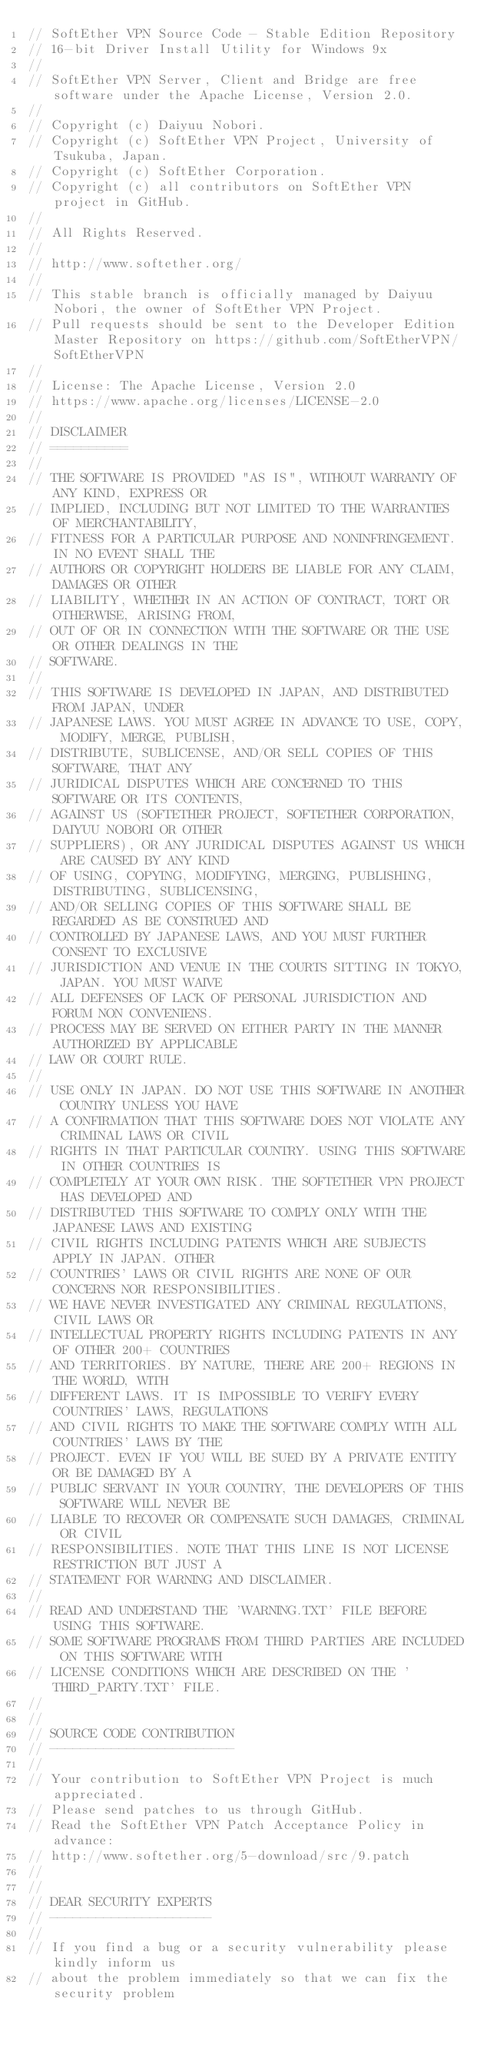Convert code to text. <code><loc_0><loc_0><loc_500><loc_500><_C_>// SoftEther VPN Source Code - Stable Edition Repository
// 16-bit Driver Install Utility for Windows 9x
// 
// SoftEther VPN Server, Client and Bridge are free software under the Apache License, Version 2.0.
// 
// Copyright (c) Daiyuu Nobori.
// Copyright (c) SoftEther VPN Project, University of Tsukuba, Japan.
// Copyright (c) SoftEther Corporation.
// Copyright (c) all contributors on SoftEther VPN project in GitHub.
// 
// All Rights Reserved.
// 
// http://www.softether.org/
// 
// This stable branch is officially managed by Daiyuu Nobori, the owner of SoftEther VPN Project.
// Pull requests should be sent to the Developer Edition Master Repository on https://github.com/SoftEtherVPN/SoftEtherVPN
// 
// License: The Apache License, Version 2.0
// https://www.apache.org/licenses/LICENSE-2.0
// 
// DISCLAIMER
// ==========
// 
// THE SOFTWARE IS PROVIDED "AS IS", WITHOUT WARRANTY OF ANY KIND, EXPRESS OR
// IMPLIED, INCLUDING BUT NOT LIMITED TO THE WARRANTIES OF MERCHANTABILITY,
// FITNESS FOR A PARTICULAR PURPOSE AND NONINFRINGEMENT. IN NO EVENT SHALL THE
// AUTHORS OR COPYRIGHT HOLDERS BE LIABLE FOR ANY CLAIM, DAMAGES OR OTHER
// LIABILITY, WHETHER IN AN ACTION OF CONTRACT, TORT OR OTHERWISE, ARISING FROM,
// OUT OF OR IN CONNECTION WITH THE SOFTWARE OR THE USE OR OTHER DEALINGS IN THE
// SOFTWARE.
// 
// THIS SOFTWARE IS DEVELOPED IN JAPAN, AND DISTRIBUTED FROM JAPAN, UNDER
// JAPANESE LAWS. YOU MUST AGREE IN ADVANCE TO USE, COPY, MODIFY, MERGE, PUBLISH,
// DISTRIBUTE, SUBLICENSE, AND/OR SELL COPIES OF THIS SOFTWARE, THAT ANY
// JURIDICAL DISPUTES WHICH ARE CONCERNED TO THIS SOFTWARE OR ITS CONTENTS,
// AGAINST US (SOFTETHER PROJECT, SOFTETHER CORPORATION, DAIYUU NOBORI OR OTHER
// SUPPLIERS), OR ANY JURIDICAL DISPUTES AGAINST US WHICH ARE CAUSED BY ANY KIND
// OF USING, COPYING, MODIFYING, MERGING, PUBLISHING, DISTRIBUTING, SUBLICENSING,
// AND/OR SELLING COPIES OF THIS SOFTWARE SHALL BE REGARDED AS BE CONSTRUED AND
// CONTROLLED BY JAPANESE LAWS, AND YOU MUST FURTHER CONSENT TO EXCLUSIVE
// JURISDICTION AND VENUE IN THE COURTS SITTING IN TOKYO, JAPAN. YOU MUST WAIVE
// ALL DEFENSES OF LACK OF PERSONAL JURISDICTION AND FORUM NON CONVENIENS.
// PROCESS MAY BE SERVED ON EITHER PARTY IN THE MANNER AUTHORIZED BY APPLICABLE
// LAW OR COURT RULE.
// 
// USE ONLY IN JAPAN. DO NOT USE THIS SOFTWARE IN ANOTHER COUNTRY UNLESS YOU HAVE
// A CONFIRMATION THAT THIS SOFTWARE DOES NOT VIOLATE ANY CRIMINAL LAWS OR CIVIL
// RIGHTS IN THAT PARTICULAR COUNTRY. USING THIS SOFTWARE IN OTHER COUNTRIES IS
// COMPLETELY AT YOUR OWN RISK. THE SOFTETHER VPN PROJECT HAS DEVELOPED AND
// DISTRIBUTED THIS SOFTWARE TO COMPLY ONLY WITH THE JAPANESE LAWS AND EXISTING
// CIVIL RIGHTS INCLUDING PATENTS WHICH ARE SUBJECTS APPLY IN JAPAN. OTHER
// COUNTRIES' LAWS OR CIVIL RIGHTS ARE NONE OF OUR CONCERNS NOR RESPONSIBILITIES.
// WE HAVE NEVER INVESTIGATED ANY CRIMINAL REGULATIONS, CIVIL LAWS OR
// INTELLECTUAL PROPERTY RIGHTS INCLUDING PATENTS IN ANY OF OTHER 200+ COUNTRIES
// AND TERRITORIES. BY NATURE, THERE ARE 200+ REGIONS IN THE WORLD, WITH
// DIFFERENT LAWS. IT IS IMPOSSIBLE TO VERIFY EVERY COUNTRIES' LAWS, REGULATIONS
// AND CIVIL RIGHTS TO MAKE THE SOFTWARE COMPLY WITH ALL COUNTRIES' LAWS BY THE
// PROJECT. EVEN IF YOU WILL BE SUED BY A PRIVATE ENTITY OR BE DAMAGED BY A
// PUBLIC SERVANT IN YOUR COUNTRY, THE DEVELOPERS OF THIS SOFTWARE WILL NEVER BE
// LIABLE TO RECOVER OR COMPENSATE SUCH DAMAGES, CRIMINAL OR CIVIL
// RESPONSIBILITIES. NOTE THAT THIS LINE IS NOT LICENSE RESTRICTION BUT JUST A
// STATEMENT FOR WARNING AND DISCLAIMER.
// 
// READ AND UNDERSTAND THE 'WARNING.TXT' FILE BEFORE USING THIS SOFTWARE.
// SOME SOFTWARE PROGRAMS FROM THIRD PARTIES ARE INCLUDED ON THIS SOFTWARE WITH
// LICENSE CONDITIONS WHICH ARE DESCRIBED ON THE 'THIRD_PARTY.TXT' FILE.
// 
// 
// SOURCE CODE CONTRIBUTION
// ------------------------
// 
// Your contribution to SoftEther VPN Project is much appreciated.
// Please send patches to us through GitHub.
// Read the SoftEther VPN Patch Acceptance Policy in advance:
// http://www.softether.org/5-download/src/9.patch
// 
// 
// DEAR SECURITY EXPERTS
// ---------------------
// 
// If you find a bug or a security vulnerability please kindly inform us
// about the problem immediately so that we can fix the security problem</code> 